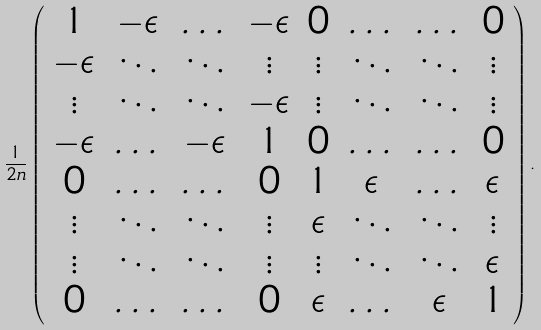Convert formula to latex. <formula><loc_0><loc_0><loc_500><loc_500>\frac { 1 } { 2 n } \left ( \begin{array} { c c c c c c c c } 1 & - \epsilon & \dots & - \epsilon & 0 & \dots & \dots & 0 \\ - \epsilon & \ddots & \ddots & \vdots & \vdots & \ddots & \ddots & \vdots \\ \vdots & \ddots & \ddots & - \epsilon & \vdots & \ddots & \ddots & \vdots \\ - \epsilon & \dots & - \epsilon & 1 & 0 & \dots & \dots & 0 \\ 0 & \dots & \dots & 0 & 1 & \epsilon & \dots & \epsilon \\ \vdots & \ddots & \ddots & \vdots & \epsilon & \ddots & \ddots & \vdots \\ \vdots & \ddots & \ddots & \vdots & \vdots & \ddots & \ddots & \epsilon \\ 0 & \dots & \dots & 0 & \epsilon & \dots & \epsilon & 1 \end{array} \right ) .</formula> 